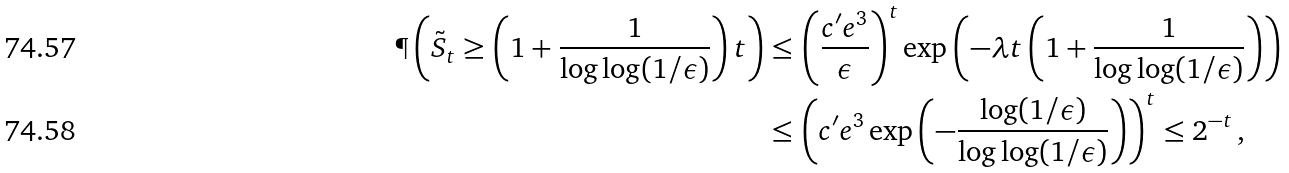<formula> <loc_0><loc_0><loc_500><loc_500>\P \left ( \tilde { S } _ { t } \geq \left ( 1 + \frac { 1 } { \log \log ( 1 / \epsilon ) } \right ) t \right ) & \leq \left ( \frac { c ^ { \prime } e ^ { 3 } } { \epsilon } \right ) ^ { t } \exp \left ( - \lambda t \left ( 1 + \frac { 1 } { \log \log ( 1 / \epsilon ) } \right ) \right ) \\ & \leq \left ( c ^ { \prime } e ^ { 3 } \exp \left ( - \frac { \log ( 1 / \epsilon ) } { \log \log ( 1 / \epsilon ) } \right ) \right ) ^ { t } \leq 2 ^ { - t } \, ,</formula> 